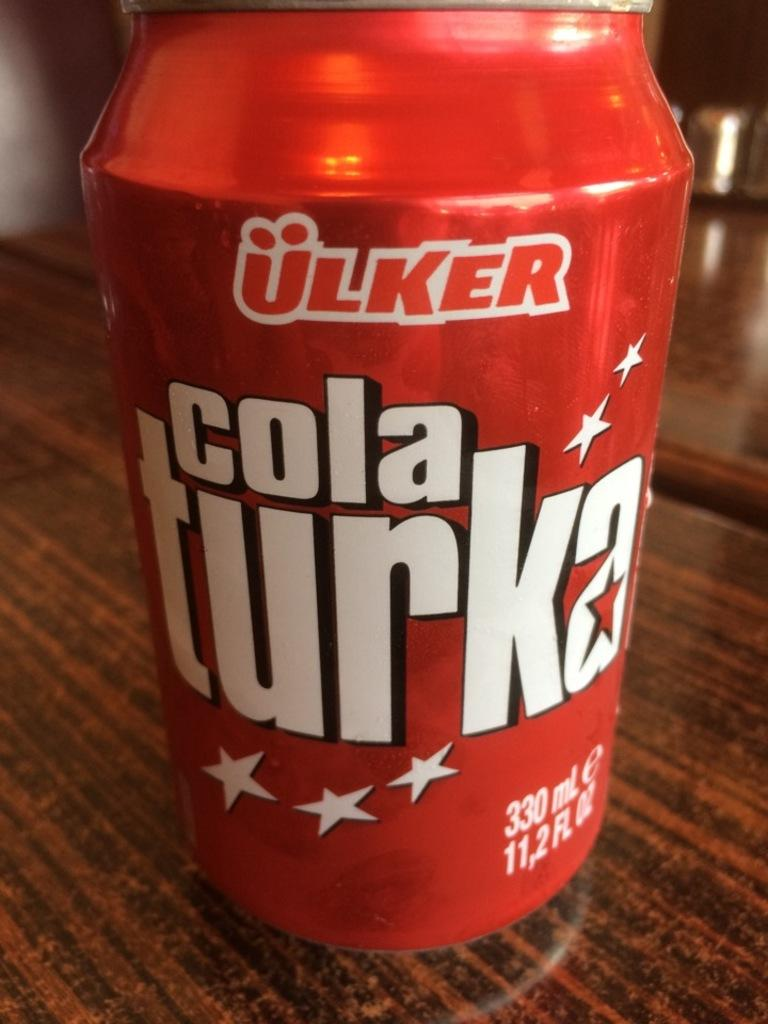<image>
Write a terse but informative summary of the picture. A red container with a label cola turka on front. 